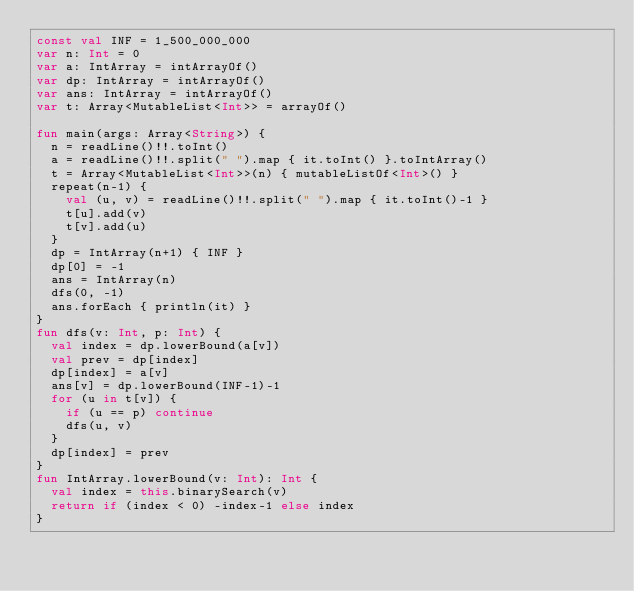Convert code to text. <code><loc_0><loc_0><loc_500><loc_500><_Kotlin_>const val INF = 1_500_000_000
var n: Int = 0
var a: IntArray = intArrayOf()
var dp: IntArray = intArrayOf()
var ans: IntArray = intArrayOf()
var t: Array<MutableList<Int>> = arrayOf()

fun main(args: Array<String>) {
  n = readLine()!!.toInt()
  a = readLine()!!.split(" ").map { it.toInt() }.toIntArray()
  t = Array<MutableList<Int>>(n) { mutableListOf<Int>() }
  repeat(n-1) {
    val (u, v) = readLine()!!.split(" ").map { it.toInt()-1 }
    t[u].add(v)
    t[v].add(u)
  }
  dp = IntArray(n+1) { INF }
  dp[0] = -1
  ans = IntArray(n)
  dfs(0, -1)
  ans.forEach { println(it) }
}
fun dfs(v: Int, p: Int) {
  val index = dp.lowerBound(a[v])
  val prev = dp[index]
  dp[index] = a[v]
  ans[v] = dp.lowerBound(INF-1)-1
  for (u in t[v]) {
    if (u == p) continue
    dfs(u, v)
  }
  dp[index] = prev
}
fun IntArray.lowerBound(v: Int): Int {
  val index = this.binarySearch(v)
  return if (index < 0) -index-1 else index
}</code> 